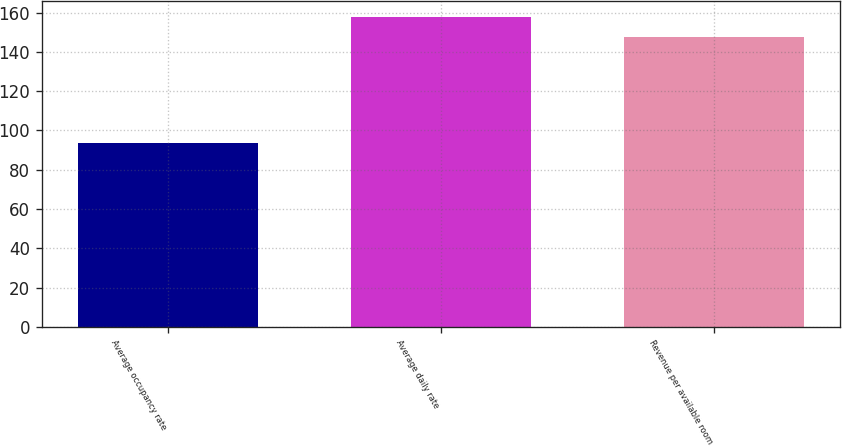Convert chart to OTSL. <chart><loc_0><loc_0><loc_500><loc_500><bar_chart><fcel>Average occupancy rate<fcel>Average daily rate<fcel>Revenue per available room<nl><fcel>93.4<fcel>158.01<fcel>147.63<nl></chart> 